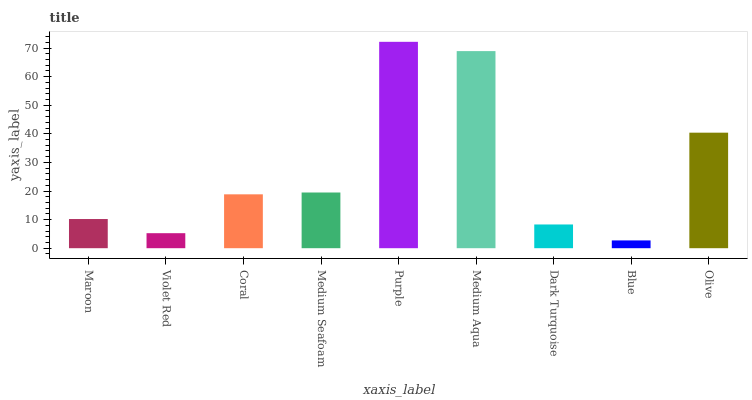Is Blue the minimum?
Answer yes or no. Yes. Is Purple the maximum?
Answer yes or no. Yes. Is Violet Red the minimum?
Answer yes or no. No. Is Violet Red the maximum?
Answer yes or no. No. Is Maroon greater than Violet Red?
Answer yes or no. Yes. Is Violet Red less than Maroon?
Answer yes or no. Yes. Is Violet Red greater than Maroon?
Answer yes or no. No. Is Maroon less than Violet Red?
Answer yes or no. No. Is Coral the high median?
Answer yes or no. Yes. Is Coral the low median?
Answer yes or no. Yes. Is Violet Red the high median?
Answer yes or no. No. Is Medium Aqua the low median?
Answer yes or no. No. 